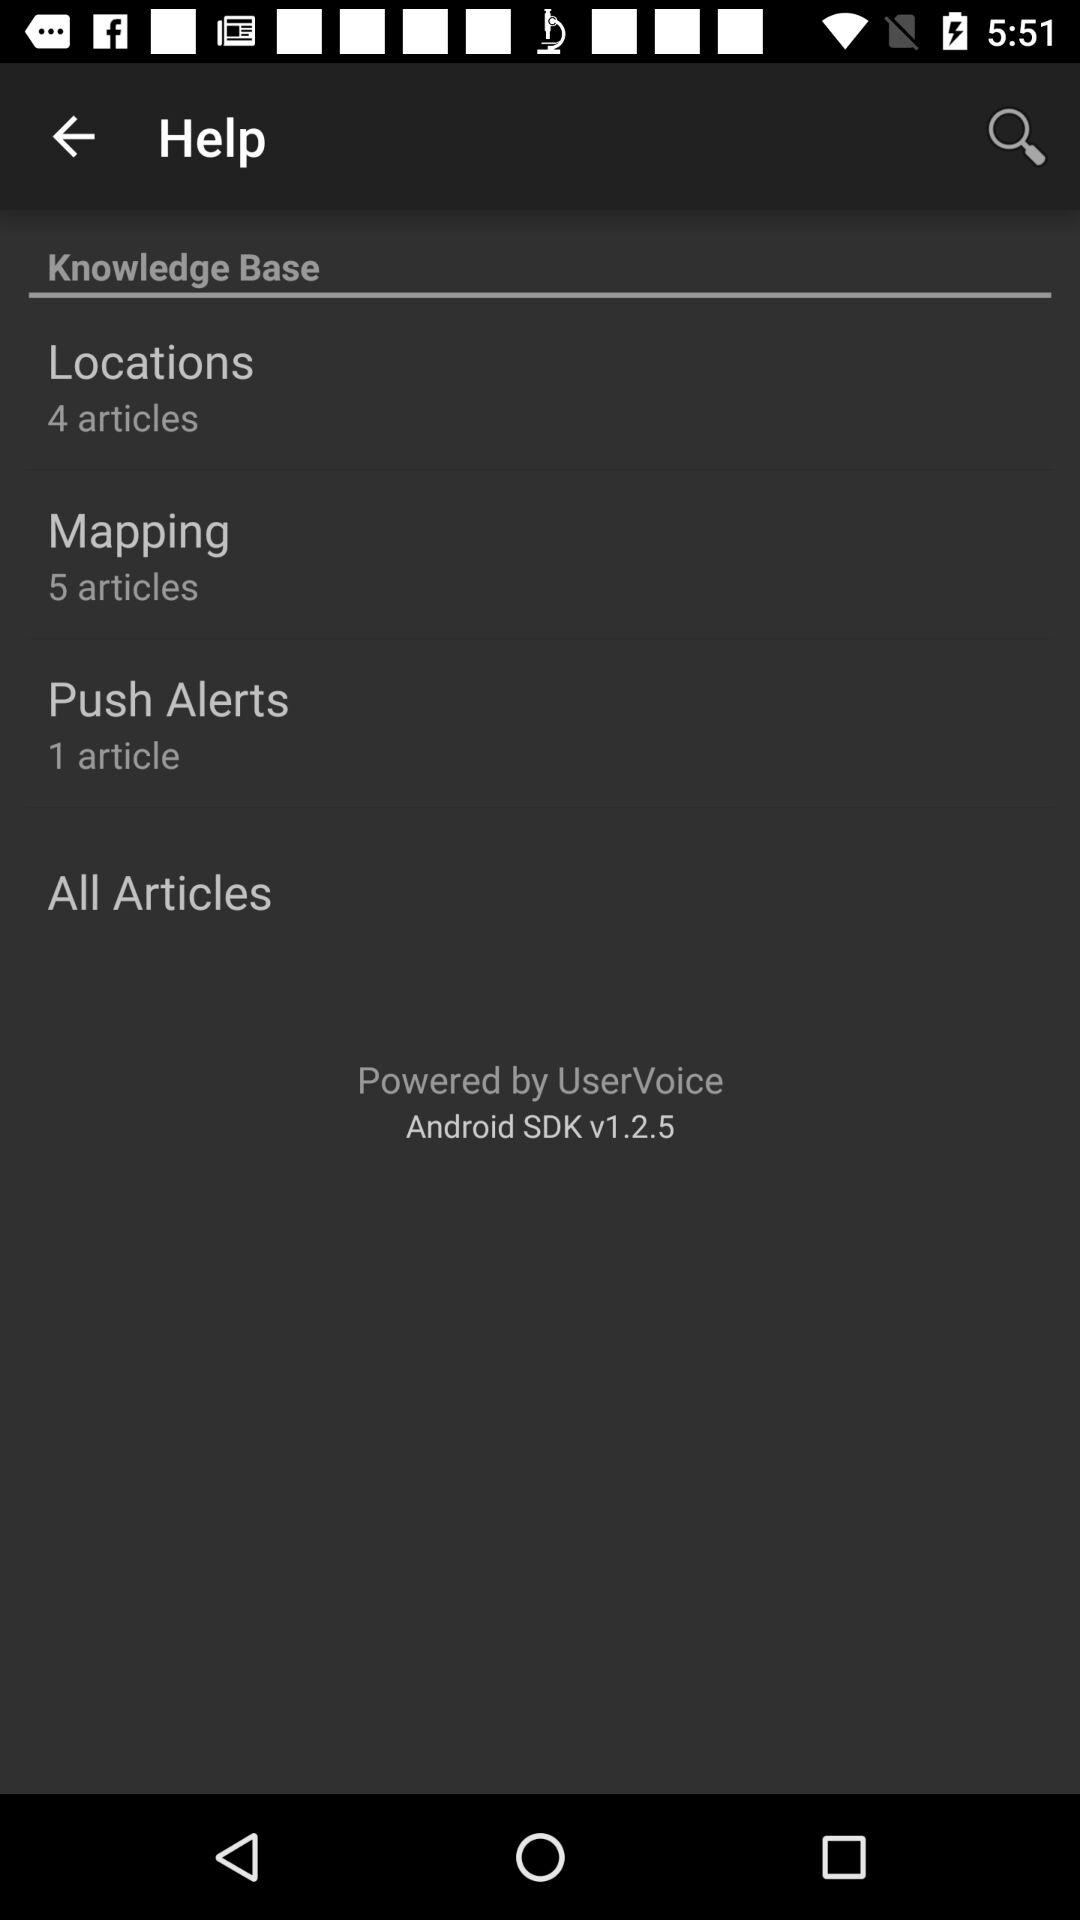What is the number of articles in "Locations"? The number of articles in "Locations" is 4. 